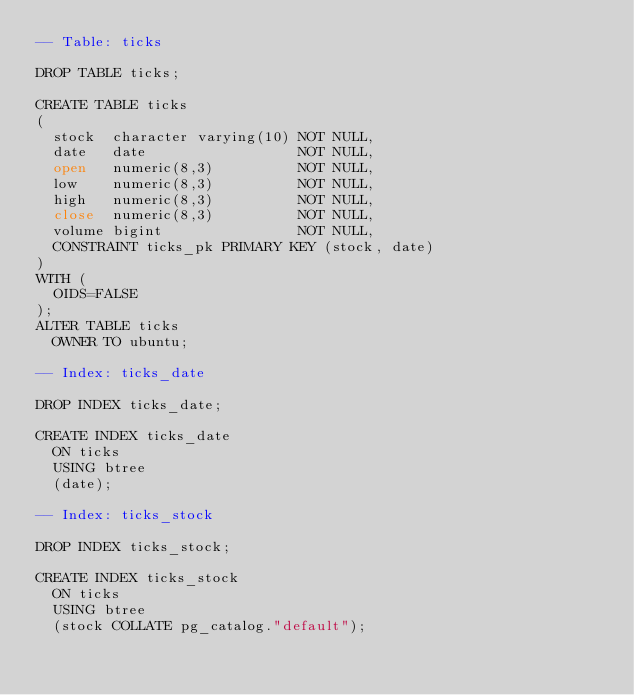Convert code to text. <code><loc_0><loc_0><loc_500><loc_500><_SQL_>-- Table: ticks

DROP TABLE ticks;

CREATE TABLE ticks
(
  stock  character varying(10) NOT NULL,
  date   date                  NOT NULL,
  open   numeric(8,3)          NOT NULL,
  low    numeric(8,3)          NOT NULL,
  high   numeric(8,3)          NOT NULL,
  close  numeric(8,3)          NOT NULL,
  volume bigint                NOT NULL,
  CONSTRAINT ticks_pk PRIMARY KEY (stock, date)
)
WITH (
  OIDS=FALSE
);
ALTER TABLE ticks
  OWNER TO ubuntu;

-- Index: ticks_date

DROP INDEX ticks_date;

CREATE INDEX ticks_date
  ON ticks
  USING btree
  (date);

-- Index: ticks_stock

DROP INDEX ticks_stock;

CREATE INDEX ticks_stock
  ON ticks
  USING btree
  (stock COLLATE pg_catalog."default");

</code> 